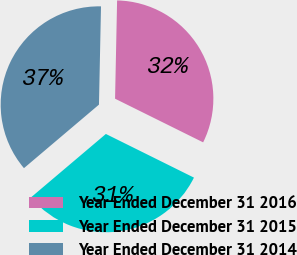<chart> <loc_0><loc_0><loc_500><loc_500><pie_chart><fcel>Year Ended December 31 2016<fcel>Year Ended December 31 2015<fcel>Year Ended December 31 2014<nl><fcel>31.99%<fcel>31.49%<fcel>36.51%<nl></chart> 